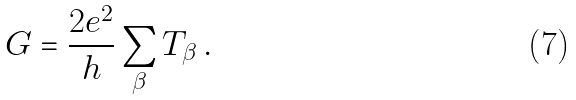<formula> <loc_0><loc_0><loc_500><loc_500>G = \frac { 2 e ^ { 2 } } { h } \sum _ { \beta } T _ { \beta } \, .</formula> 